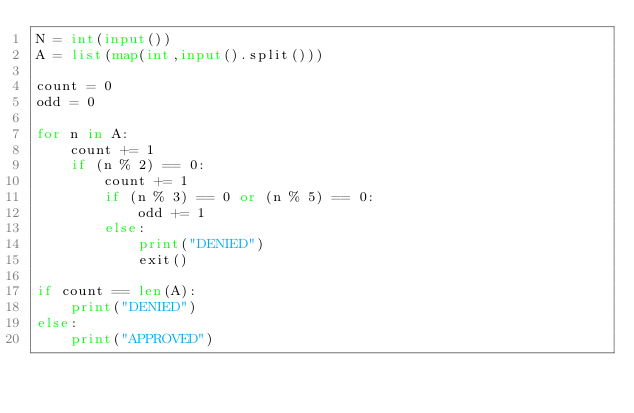Convert code to text. <code><loc_0><loc_0><loc_500><loc_500><_Python_>N = int(input())
A = list(map(int,input().split()))

count = 0
odd = 0

for n in A:
    count += 1
    if (n % 2) == 0:
        count += 1
        if (n % 3) == 0 or (n % 5) == 0:
            odd += 1
        else:
            print("DENIED")
            exit()

if count == len(A):
    print("DENIED")
else:
    print("APPROVED")
</code> 